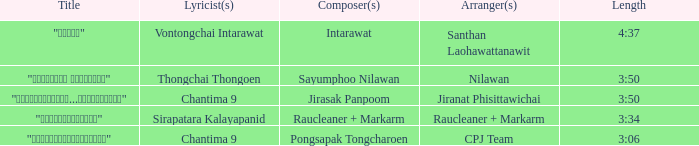Who was the arranger of "ขอโทษ"? Santhan Laohawattanawit. 